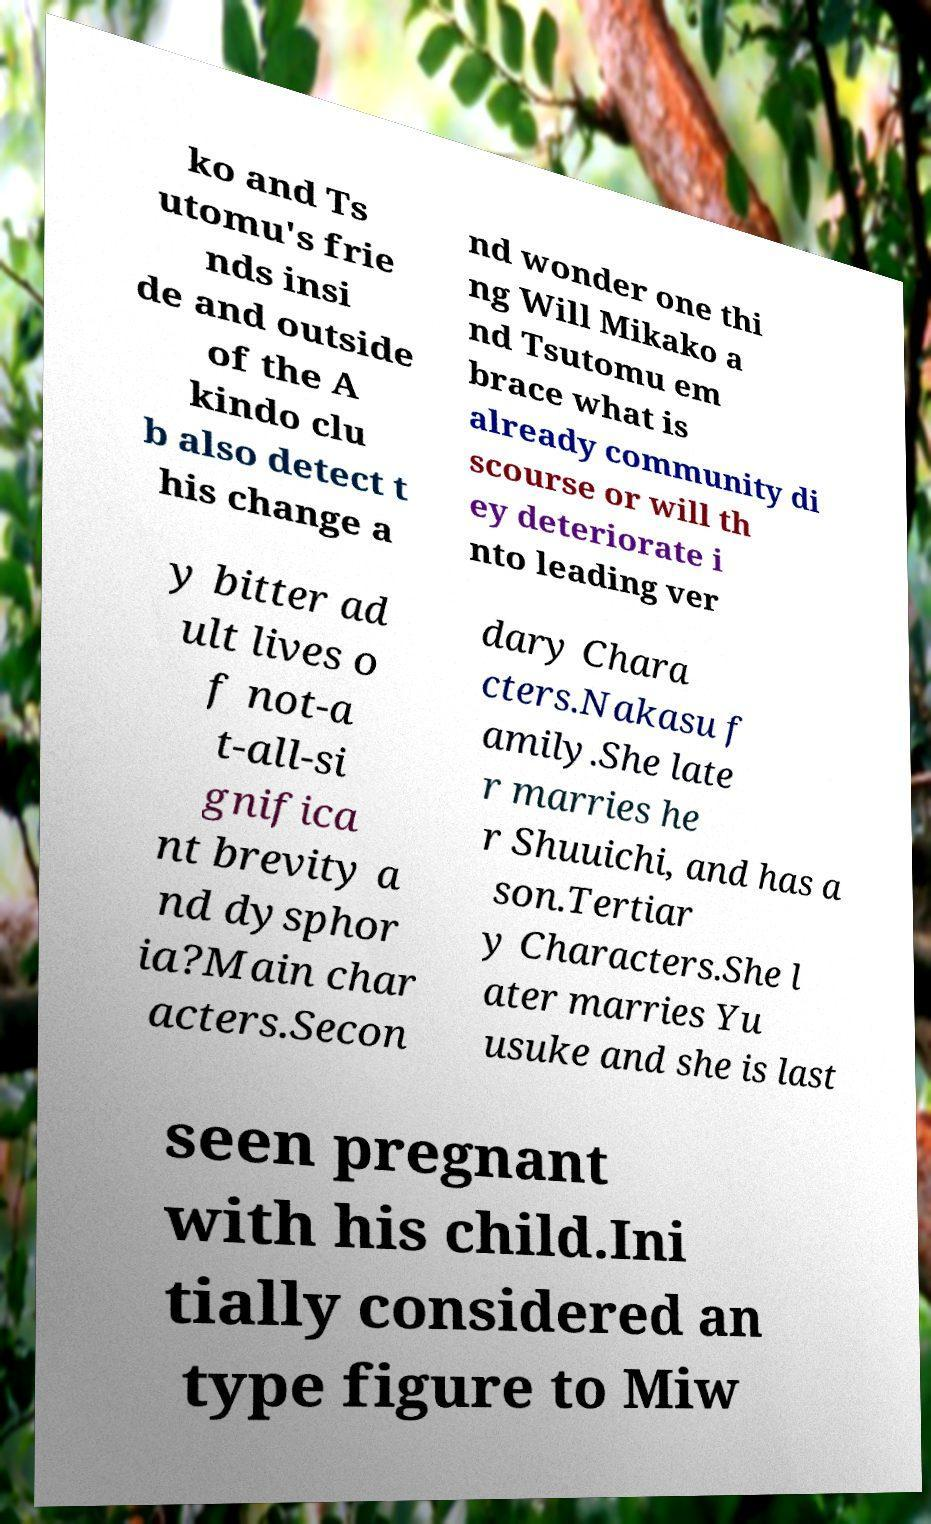Please identify and transcribe the text found in this image. ko and Ts utomu's frie nds insi de and outside of the A kindo clu b also detect t his change a nd wonder one thi ng Will Mikako a nd Tsutomu em brace what is already community di scourse or will th ey deteriorate i nto leading ver y bitter ad ult lives o f not-a t-all-si gnifica nt brevity a nd dysphor ia?Main char acters.Secon dary Chara cters.Nakasu f amily.She late r marries he r Shuuichi, and has a son.Tertiar y Characters.She l ater marries Yu usuke and she is last seen pregnant with his child.Ini tially considered an type figure to Miw 